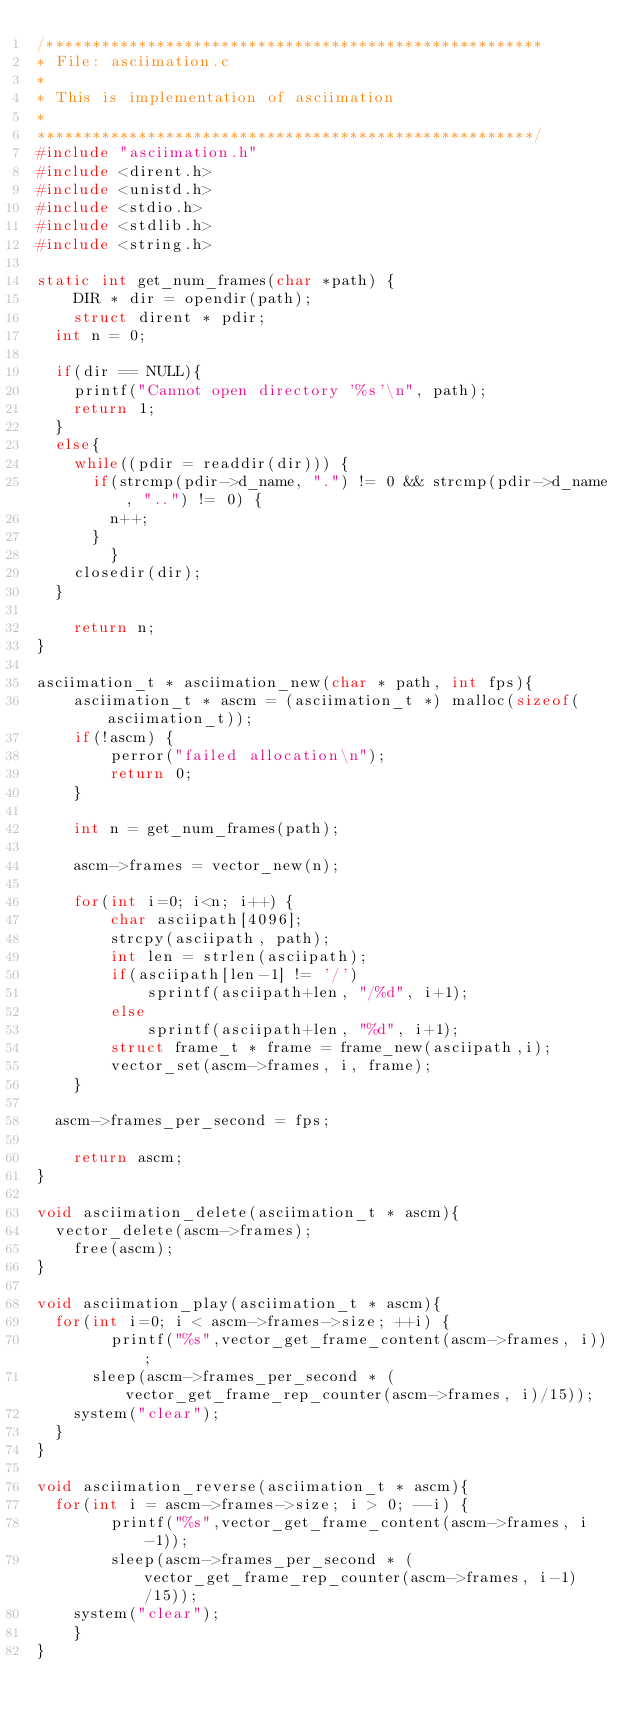Convert code to text. <code><loc_0><loc_0><loc_500><loc_500><_C_>/******************************************************
* File: asciimation.c
*
* This is implementation of asciimation
*
******************************************************/
#include "asciimation.h"
#include <dirent.h>
#include <unistd.h>
#include <stdio.h>
#include <stdlib.h>
#include <string.h>

static int get_num_frames(char *path) {
	DIR * dir = opendir(path);
	struct dirent * pdir;
  int n = 0;

  if(dir == NULL){
    printf("Cannot open directory '%s'\n", path);
    return 1;
  }
  else{
    while((pdir = readdir(dir))) {
      if(strcmp(pdir->d_name, ".") != 0 && strcmp(pdir->d_name, "..") != 0) {
        n++;
      }
		}
    closedir(dir);
  }

	return n;
}

asciimation_t * asciimation_new(char * path, int fps){
	asciimation_t * ascm = (asciimation_t *) malloc(sizeof(asciimation_t));
	if(!ascm) {
		perror("failed allocation\n");
		return 0;
	}

	int n = get_num_frames(path);

	ascm->frames = vector_new(n);

	for(int i=0; i<n; i++) {
		char asciipath[4096];
		strcpy(asciipath, path);
		int len = strlen(asciipath);
		if(asciipath[len-1] != '/') 
			sprintf(asciipath+len, "/%d", i+1);
		else
			sprintf(asciipath+len, "%d", i+1);
		struct frame_t * frame = frame_new(asciipath,i);
		vector_set(ascm->frames, i, frame);
	}
  
  ascm->frames_per_second = fps;

	return ascm;
}

void asciimation_delete(asciimation_t * ascm){
  vector_delete(ascm->frames);
	free(ascm);
}

void asciimation_play(asciimation_t * ascm){
  for(int i=0; i < ascm->frames->size; ++i) {
		printf("%s",vector_get_frame_content(ascm->frames, i));
	  sleep(ascm->frames_per_second * (vector_get_frame_rep_counter(ascm->frames, i)/15));
    system("clear");
  }
}

void asciimation_reverse(asciimation_t * ascm){
  for(int i = ascm->frames->size; i > 0; --i) {
		printf("%s",vector_get_frame_content(ascm->frames, i-1));
		sleep(ascm->frames_per_second * (vector_get_frame_rep_counter(ascm->frames, i-1)/15));
    system("clear");
	}
}</code> 